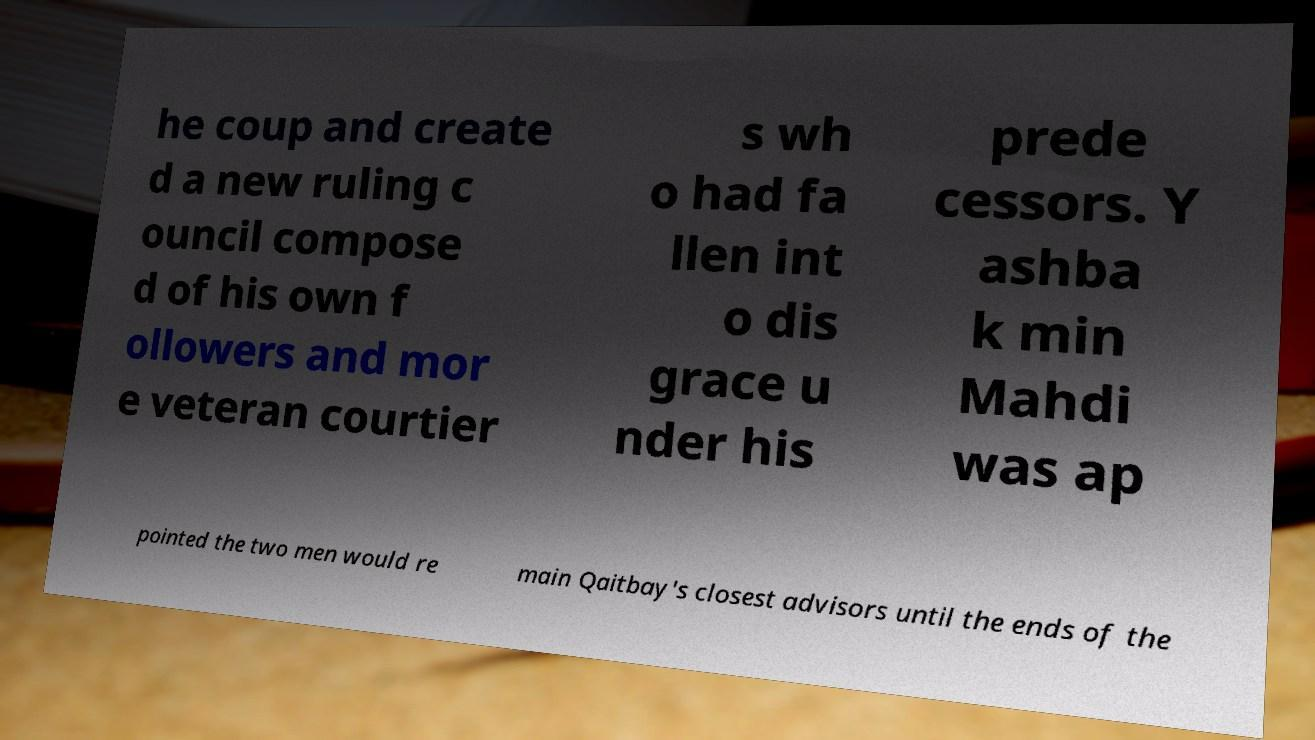What messages or text are displayed in this image? I need them in a readable, typed format. he coup and create d a new ruling c ouncil compose d of his own f ollowers and mor e veteran courtier s wh o had fa llen int o dis grace u nder his prede cessors. Y ashba k min Mahdi was ap pointed the two men would re main Qaitbay's closest advisors until the ends of the 